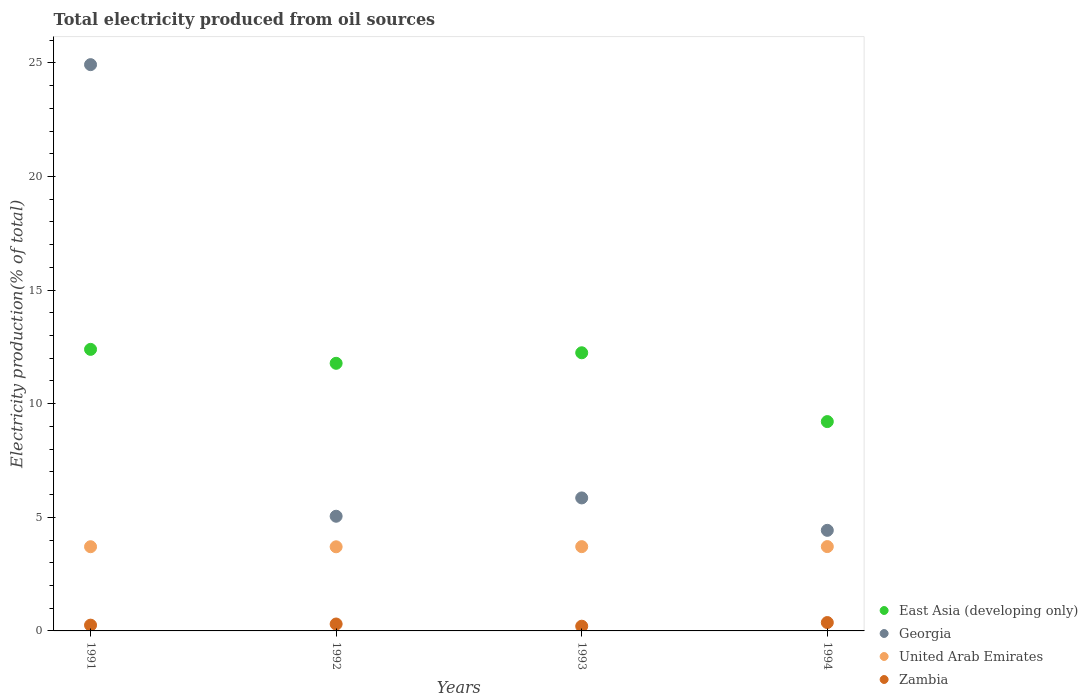How many different coloured dotlines are there?
Keep it short and to the point. 4. What is the total electricity produced in East Asia (developing only) in 1991?
Give a very brief answer. 12.39. Across all years, what is the maximum total electricity produced in United Arab Emirates?
Make the answer very short. 3.71. Across all years, what is the minimum total electricity produced in United Arab Emirates?
Provide a succinct answer. 3.7. In which year was the total electricity produced in United Arab Emirates maximum?
Ensure brevity in your answer.  1994. In which year was the total electricity produced in United Arab Emirates minimum?
Keep it short and to the point. 1992. What is the total total electricity produced in Zambia in the graph?
Provide a succinct answer. 1.13. What is the difference between the total electricity produced in Zambia in 1991 and that in 1992?
Your answer should be compact. -0.05. What is the difference between the total electricity produced in United Arab Emirates in 1993 and the total electricity produced in Zambia in 1991?
Your answer should be compact. 3.45. What is the average total electricity produced in United Arab Emirates per year?
Offer a terse response. 3.71. In the year 1993, what is the difference between the total electricity produced in East Asia (developing only) and total electricity produced in Georgia?
Offer a terse response. 6.39. What is the ratio of the total electricity produced in United Arab Emirates in 1992 to that in 1994?
Offer a terse response. 1. Is the total electricity produced in United Arab Emirates in 1993 less than that in 1994?
Your response must be concise. Yes. What is the difference between the highest and the second highest total electricity produced in Zambia?
Your response must be concise. 0.06. What is the difference between the highest and the lowest total electricity produced in East Asia (developing only)?
Offer a very short reply. 3.18. In how many years, is the total electricity produced in Georgia greater than the average total electricity produced in Georgia taken over all years?
Make the answer very short. 1. Is the sum of the total electricity produced in United Arab Emirates in 1991 and 1992 greater than the maximum total electricity produced in East Asia (developing only) across all years?
Offer a very short reply. No. Is it the case that in every year, the sum of the total electricity produced in United Arab Emirates and total electricity produced in Georgia  is greater than the total electricity produced in Zambia?
Provide a short and direct response. Yes. How many dotlines are there?
Offer a terse response. 4. How many years are there in the graph?
Make the answer very short. 4. What is the difference between two consecutive major ticks on the Y-axis?
Offer a terse response. 5. Are the values on the major ticks of Y-axis written in scientific E-notation?
Make the answer very short. No. Does the graph contain any zero values?
Keep it short and to the point. No. Does the graph contain grids?
Offer a very short reply. No. Where does the legend appear in the graph?
Ensure brevity in your answer.  Bottom right. How many legend labels are there?
Give a very brief answer. 4. What is the title of the graph?
Make the answer very short. Total electricity produced from oil sources. What is the label or title of the X-axis?
Keep it short and to the point. Years. What is the Electricity production(% of total) in East Asia (developing only) in 1991?
Your answer should be compact. 12.39. What is the Electricity production(% of total) in Georgia in 1991?
Your response must be concise. 24.92. What is the Electricity production(% of total) in United Arab Emirates in 1991?
Your response must be concise. 3.71. What is the Electricity production(% of total) in Zambia in 1991?
Offer a very short reply. 0.25. What is the Electricity production(% of total) in East Asia (developing only) in 1992?
Offer a very short reply. 11.78. What is the Electricity production(% of total) of Georgia in 1992?
Make the answer very short. 5.05. What is the Electricity production(% of total) of United Arab Emirates in 1992?
Ensure brevity in your answer.  3.7. What is the Electricity production(% of total) in Zambia in 1992?
Your answer should be compact. 0.3. What is the Electricity production(% of total) of East Asia (developing only) in 1993?
Give a very brief answer. 12.24. What is the Electricity production(% of total) of Georgia in 1993?
Give a very brief answer. 5.85. What is the Electricity production(% of total) of United Arab Emirates in 1993?
Ensure brevity in your answer.  3.71. What is the Electricity production(% of total) in Zambia in 1993?
Your answer should be very brief. 0.21. What is the Electricity production(% of total) in East Asia (developing only) in 1994?
Keep it short and to the point. 9.21. What is the Electricity production(% of total) in Georgia in 1994?
Offer a terse response. 4.43. What is the Electricity production(% of total) of United Arab Emirates in 1994?
Offer a terse response. 3.71. What is the Electricity production(% of total) in Zambia in 1994?
Offer a terse response. 0.37. Across all years, what is the maximum Electricity production(% of total) of East Asia (developing only)?
Keep it short and to the point. 12.39. Across all years, what is the maximum Electricity production(% of total) in Georgia?
Provide a succinct answer. 24.92. Across all years, what is the maximum Electricity production(% of total) in United Arab Emirates?
Offer a terse response. 3.71. Across all years, what is the maximum Electricity production(% of total) of Zambia?
Offer a very short reply. 0.37. Across all years, what is the minimum Electricity production(% of total) of East Asia (developing only)?
Your answer should be compact. 9.21. Across all years, what is the minimum Electricity production(% of total) of Georgia?
Keep it short and to the point. 4.43. Across all years, what is the minimum Electricity production(% of total) in United Arab Emirates?
Provide a succinct answer. 3.7. Across all years, what is the minimum Electricity production(% of total) of Zambia?
Your response must be concise. 0.21. What is the total Electricity production(% of total) of East Asia (developing only) in the graph?
Keep it short and to the point. 45.63. What is the total Electricity production(% of total) of Georgia in the graph?
Provide a short and direct response. 40.25. What is the total Electricity production(% of total) in United Arab Emirates in the graph?
Provide a succinct answer. 14.83. What is the total Electricity production(% of total) in Zambia in the graph?
Offer a terse response. 1.13. What is the difference between the Electricity production(% of total) of East Asia (developing only) in 1991 and that in 1992?
Give a very brief answer. 0.61. What is the difference between the Electricity production(% of total) in Georgia in 1991 and that in 1992?
Your response must be concise. 19.88. What is the difference between the Electricity production(% of total) of United Arab Emirates in 1991 and that in 1992?
Your answer should be compact. 0. What is the difference between the Electricity production(% of total) of Zambia in 1991 and that in 1992?
Your answer should be compact. -0.05. What is the difference between the Electricity production(% of total) in East Asia (developing only) in 1991 and that in 1993?
Your response must be concise. 0.15. What is the difference between the Electricity production(% of total) in Georgia in 1991 and that in 1993?
Your answer should be compact. 19.07. What is the difference between the Electricity production(% of total) of United Arab Emirates in 1991 and that in 1993?
Give a very brief answer. -0. What is the difference between the Electricity production(% of total) of Zambia in 1991 and that in 1993?
Your answer should be very brief. 0.05. What is the difference between the Electricity production(% of total) of East Asia (developing only) in 1991 and that in 1994?
Provide a succinct answer. 3.18. What is the difference between the Electricity production(% of total) of Georgia in 1991 and that in 1994?
Make the answer very short. 20.5. What is the difference between the Electricity production(% of total) in United Arab Emirates in 1991 and that in 1994?
Ensure brevity in your answer.  -0.01. What is the difference between the Electricity production(% of total) in Zambia in 1991 and that in 1994?
Ensure brevity in your answer.  -0.11. What is the difference between the Electricity production(% of total) of East Asia (developing only) in 1992 and that in 1993?
Provide a short and direct response. -0.46. What is the difference between the Electricity production(% of total) in Georgia in 1992 and that in 1993?
Give a very brief answer. -0.81. What is the difference between the Electricity production(% of total) of United Arab Emirates in 1992 and that in 1993?
Ensure brevity in your answer.  -0.01. What is the difference between the Electricity production(% of total) in Zambia in 1992 and that in 1993?
Keep it short and to the point. 0.1. What is the difference between the Electricity production(% of total) in East Asia (developing only) in 1992 and that in 1994?
Your answer should be very brief. 2.57. What is the difference between the Electricity production(% of total) of Georgia in 1992 and that in 1994?
Provide a succinct answer. 0.62. What is the difference between the Electricity production(% of total) in United Arab Emirates in 1992 and that in 1994?
Provide a short and direct response. -0.01. What is the difference between the Electricity production(% of total) of Zambia in 1992 and that in 1994?
Offer a terse response. -0.06. What is the difference between the Electricity production(% of total) of East Asia (developing only) in 1993 and that in 1994?
Give a very brief answer. 3.03. What is the difference between the Electricity production(% of total) of Georgia in 1993 and that in 1994?
Your answer should be very brief. 1.43. What is the difference between the Electricity production(% of total) of United Arab Emirates in 1993 and that in 1994?
Keep it short and to the point. -0. What is the difference between the Electricity production(% of total) of Zambia in 1993 and that in 1994?
Make the answer very short. -0.16. What is the difference between the Electricity production(% of total) in East Asia (developing only) in 1991 and the Electricity production(% of total) in Georgia in 1992?
Make the answer very short. 7.34. What is the difference between the Electricity production(% of total) in East Asia (developing only) in 1991 and the Electricity production(% of total) in United Arab Emirates in 1992?
Make the answer very short. 8.69. What is the difference between the Electricity production(% of total) of East Asia (developing only) in 1991 and the Electricity production(% of total) of Zambia in 1992?
Provide a short and direct response. 12.09. What is the difference between the Electricity production(% of total) of Georgia in 1991 and the Electricity production(% of total) of United Arab Emirates in 1992?
Give a very brief answer. 21.22. What is the difference between the Electricity production(% of total) in Georgia in 1991 and the Electricity production(% of total) in Zambia in 1992?
Provide a short and direct response. 24.62. What is the difference between the Electricity production(% of total) in United Arab Emirates in 1991 and the Electricity production(% of total) in Zambia in 1992?
Give a very brief answer. 3.4. What is the difference between the Electricity production(% of total) in East Asia (developing only) in 1991 and the Electricity production(% of total) in Georgia in 1993?
Offer a terse response. 6.54. What is the difference between the Electricity production(% of total) of East Asia (developing only) in 1991 and the Electricity production(% of total) of United Arab Emirates in 1993?
Offer a very short reply. 8.68. What is the difference between the Electricity production(% of total) in East Asia (developing only) in 1991 and the Electricity production(% of total) in Zambia in 1993?
Provide a short and direct response. 12.18. What is the difference between the Electricity production(% of total) in Georgia in 1991 and the Electricity production(% of total) in United Arab Emirates in 1993?
Provide a succinct answer. 21.21. What is the difference between the Electricity production(% of total) of Georgia in 1991 and the Electricity production(% of total) of Zambia in 1993?
Offer a terse response. 24.72. What is the difference between the Electricity production(% of total) in United Arab Emirates in 1991 and the Electricity production(% of total) in Zambia in 1993?
Keep it short and to the point. 3.5. What is the difference between the Electricity production(% of total) of East Asia (developing only) in 1991 and the Electricity production(% of total) of Georgia in 1994?
Your response must be concise. 7.97. What is the difference between the Electricity production(% of total) of East Asia (developing only) in 1991 and the Electricity production(% of total) of United Arab Emirates in 1994?
Ensure brevity in your answer.  8.68. What is the difference between the Electricity production(% of total) in East Asia (developing only) in 1991 and the Electricity production(% of total) in Zambia in 1994?
Your answer should be compact. 12.02. What is the difference between the Electricity production(% of total) of Georgia in 1991 and the Electricity production(% of total) of United Arab Emirates in 1994?
Ensure brevity in your answer.  21.21. What is the difference between the Electricity production(% of total) of Georgia in 1991 and the Electricity production(% of total) of Zambia in 1994?
Offer a terse response. 24.55. What is the difference between the Electricity production(% of total) of United Arab Emirates in 1991 and the Electricity production(% of total) of Zambia in 1994?
Keep it short and to the point. 3.34. What is the difference between the Electricity production(% of total) in East Asia (developing only) in 1992 and the Electricity production(% of total) in Georgia in 1993?
Provide a succinct answer. 5.92. What is the difference between the Electricity production(% of total) in East Asia (developing only) in 1992 and the Electricity production(% of total) in United Arab Emirates in 1993?
Keep it short and to the point. 8.07. What is the difference between the Electricity production(% of total) in East Asia (developing only) in 1992 and the Electricity production(% of total) in Zambia in 1993?
Provide a succinct answer. 11.57. What is the difference between the Electricity production(% of total) in Georgia in 1992 and the Electricity production(% of total) in United Arab Emirates in 1993?
Keep it short and to the point. 1.34. What is the difference between the Electricity production(% of total) of Georgia in 1992 and the Electricity production(% of total) of Zambia in 1993?
Offer a terse response. 4.84. What is the difference between the Electricity production(% of total) of United Arab Emirates in 1992 and the Electricity production(% of total) of Zambia in 1993?
Ensure brevity in your answer.  3.5. What is the difference between the Electricity production(% of total) in East Asia (developing only) in 1992 and the Electricity production(% of total) in Georgia in 1994?
Ensure brevity in your answer.  7.35. What is the difference between the Electricity production(% of total) of East Asia (developing only) in 1992 and the Electricity production(% of total) of United Arab Emirates in 1994?
Provide a succinct answer. 8.07. What is the difference between the Electricity production(% of total) in East Asia (developing only) in 1992 and the Electricity production(% of total) in Zambia in 1994?
Provide a succinct answer. 11.41. What is the difference between the Electricity production(% of total) of Georgia in 1992 and the Electricity production(% of total) of United Arab Emirates in 1994?
Ensure brevity in your answer.  1.34. What is the difference between the Electricity production(% of total) in Georgia in 1992 and the Electricity production(% of total) in Zambia in 1994?
Give a very brief answer. 4.68. What is the difference between the Electricity production(% of total) in United Arab Emirates in 1992 and the Electricity production(% of total) in Zambia in 1994?
Offer a terse response. 3.33. What is the difference between the Electricity production(% of total) of East Asia (developing only) in 1993 and the Electricity production(% of total) of Georgia in 1994?
Make the answer very short. 7.82. What is the difference between the Electricity production(% of total) in East Asia (developing only) in 1993 and the Electricity production(% of total) in United Arab Emirates in 1994?
Offer a very short reply. 8.53. What is the difference between the Electricity production(% of total) of East Asia (developing only) in 1993 and the Electricity production(% of total) of Zambia in 1994?
Your answer should be very brief. 11.87. What is the difference between the Electricity production(% of total) in Georgia in 1993 and the Electricity production(% of total) in United Arab Emirates in 1994?
Give a very brief answer. 2.14. What is the difference between the Electricity production(% of total) in Georgia in 1993 and the Electricity production(% of total) in Zambia in 1994?
Provide a succinct answer. 5.49. What is the difference between the Electricity production(% of total) in United Arab Emirates in 1993 and the Electricity production(% of total) in Zambia in 1994?
Offer a terse response. 3.34. What is the average Electricity production(% of total) in East Asia (developing only) per year?
Your response must be concise. 11.41. What is the average Electricity production(% of total) of Georgia per year?
Keep it short and to the point. 10.06. What is the average Electricity production(% of total) in United Arab Emirates per year?
Your answer should be compact. 3.71. What is the average Electricity production(% of total) of Zambia per year?
Provide a succinct answer. 0.28. In the year 1991, what is the difference between the Electricity production(% of total) of East Asia (developing only) and Electricity production(% of total) of Georgia?
Make the answer very short. -12.53. In the year 1991, what is the difference between the Electricity production(% of total) of East Asia (developing only) and Electricity production(% of total) of United Arab Emirates?
Your answer should be compact. 8.69. In the year 1991, what is the difference between the Electricity production(% of total) of East Asia (developing only) and Electricity production(% of total) of Zambia?
Provide a short and direct response. 12.14. In the year 1991, what is the difference between the Electricity production(% of total) in Georgia and Electricity production(% of total) in United Arab Emirates?
Offer a terse response. 21.22. In the year 1991, what is the difference between the Electricity production(% of total) of Georgia and Electricity production(% of total) of Zambia?
Your answer should be compact. 24.67. In the year 1991, what is the difference between the Electricity production(% of total) in United Arab Emirates and Electricity production(% of total) in Zambia?
Offer a terse response. 3.45. In the year 1992, what is the difference between the Electricity production(% of total) in East Asia (developing only) and Electricity production(% of total) in Georgia?
Provide a succinct answer. 6.73. In the year 1992, what is the difference between the Electricity production(% of total) of East Asia (developing only) and Electricity production(% of total) of United Arab Emirates?
Provide a succinct answer. 8.08. In the year 1992, what is the difference between the Electricity production(% of total) in East Asia (developing only) and Electricity production(% of total) in Zambia?
Your response must be concise. 11.47. In the year 1992, what is the difference between the Electricity production(% of total) of Georgia and Electricity production(% of total) of United Arab Emirates?
Offer a very short reply. 1.34. In the year 1992, what is the difference between the Electricity production(% of total) of Georgia and Electricity production(% of total) of Zambia?
Offer a very short reply. 4.74. In the year 1992, what is the difference between the Electricity production(% of total) in United Arab Emirates and Electricity production(% of total) in Zambia?
Provide a short and direct response. 3.4. In the year 1993, what is the difference between the Electricity production(% of total) in East Asia (developing only) and Electricity production(% of total) in Georgia?
Give a very brief answer. 6.39. In the year 1993, what is the difference between the Electricity production(% of total) of East Asia (developing only) and Electricity production(% of total) of United Arab Emirates?
Keep it short and to the point. 8.53. In the year 1993, what is the difference between the Electricity production(% of total) of East Asia (developing only) and Electricity production(% of total) of Zambia?
Your answer should be very brief. 12.03. In the year 1993, what is the difference between the Electricity production(% of total) of Georgia and Electricity production(% of total) of United Arab Emirates?
Provide a short and direct response. 2.14. In the year 1993, what is the difference between the Electricity production(% of total) in Georgia and Electricity production(% of total) in Zambia?
Make the answer very short. 5.65. In the year 1993, what is the difference between the Electricity production(% of total) of United Arab Emirates and Electricity production(% of total) of Zambia?
Your answer should be very brief. 3.5. In the year 1994, what is the difference between the Electricity production(% of total) of East Asia (developing only) and Electricity production(% of total) of Georgia?
Make the answer very short. 4.79. In the year 1994, what is the difference between the Electricity production(% of total) of East Asia (developing only) and Electricity production(% of total) of United Arab Emirates?
Make the answer very short. 5.5. In the year 1994, what is the difference between the Electricity production(% of total) of East Asia (developing only) and Electricity production(% of total) of Zambia?
Your answer should be very brief. 8.84. In the year 1994, what is the difference between the Electricity production(% of total) in Georgia and Electricity production(% of total) in United Arab Emirates?
Keep it short and to the point. 0.71. In the year 1994, what is the difference between the Electricity production(% of total) in Georgia and Electricity production(% of total) in Zambia?
Provide a succinct answer. 4.06. In the year 1994, what is the difference between the Electricity production(% of total) of United Arab Emirates and Electricity production(% of total) of Zambia?
Provide a succinct answer. 3.34. What is the ratio of the Electricity production(% of total) of East Asia (developing only) in 1991 to that in 1992?
Keep it short and to the point. 1.05. What is the ratio of the Electricity production(% of total) of Georgia in 1991 to that in 1992?
Offer a very short reply. 4.94. What is the ratio of the Electricity production(% of total) in United Arab Emirates in 1991 to that in 1992?
Make the answer very short. 1. What is the ratio of the Electricity production(% of total) in Zambia in 1991 to that in 1992?
Ensure brevity in your answer.  0.84. What is the ratio of the Electricity production(% of total) of East Asia (developing only) in 1991 to that in 1993?
Keep it short and to the point. 1.01. What is the ratio of the Electricity production(% of total) in Georgia in 1991 to that in 1993?
Offer a terse response. 4.26. What is the ratio of the Electricity production(% of total) of United Arab Emirates in 1991 to that in 1993?
Keep it short and to the point. 1. What is the ratio of the Electricity production(% of total) in Zambia in 1991 to that in 1993?
Provide a short and direct response. 1.23. What is the ratio of the Electricity production(% of total) in East Asia (developing only) in 1991 to that in 1994?
Give a very brief answer. 1.34. What is the ratio of the Electricity production(% of total) in Georgia in 1991 to that in 1994?
Provide a succinct answer. 5.63. What is the ratio of the Electricity production(% of total) in United Arab Emirates in 1991 to that in 1994?
Provide a succinct answer. 1. What is the ratio of the Electricity production(% of total) in Zambia in 1991 to that in 1994?
Your answer should be very brief. 0.69. What is the ratio of the Electricity production(% of total) of East Asia (developing only) in 1992 to that in 1993?
Your response must be concise. 0.96. What is the ratio of the Electricity production(% of total) of Georgia in 1992 to that in 1993?
Keep it short and to the point. 0.86. What is the ratio of the Electricity production(% of total) in United Arab Emirates in 1992 to that in 1993?
Offer a very short reply. 1. What is the ratio of the Electricity production(% of total) in Zambia in 1992 to that in 1993?
Your answer should be very brief. 1.47. What is the ratio of the Electricity production(% of total) of East Asia (developing only) in 1992 to that in 1994?
Your response must be concise. 1.28. What is the ratio of the Electricity production(% of total) in Georgia in 1992 to that in 1994?
Your answer should be compact. 1.14. What is the ratio of the Electricity production(% of total) of Zambia in 1992 to that in 1994?
Give a very brief answer. 0.83. What is the ratio of the Electricity production(% of total) in East Asia (developing only) in 1993 to that in 1994?
Your answer should be compact. 1.33. What is the ratio of the Electricity production(% of total) of Georgia in 1993 to that in 1994?
Give a very brief answer. 1.32. What is the ratio of the Electricity production(% of total) in United Arab Emirates in 1993 to that in 1994?
Offer a very short reply. 1. What is the ratio of the Electricity production(% of total) in Zambia in 1993 to that in 1994?
Offer a very short reply. 0.56. What is the difference between the highest and the second highest Electricity production(% of total) of East Asia (developing only)?
Offer a very short reply. 0.15. What is the difference between the highest and the second highest Electricity production(% of total) in Georgia?
Keep it short and to the point. 19.07. What is the difference between the highest and the second highest Electricity production(% of total) in United Arab Emirates?
Your response must be concise. 0. What is the difference between the highest and the second highest Electricity production(% of total) of Zambia?
Offer a very short reply. 0.06. What is the difference between the highest and the lowest Electricity production(% of total) in East Asia (developing only)?
Make the answer very short. 3.18. What is the difference between the highest and the lowest Electricity production(% of total) of Georgia?
Provide a succinct answer. 20.5. What is the difference between the highest and the lowest Electricity production(% of total) in United Arab Emirates?
Ensure brevity in your answer.  0.01. What is the difference between the highest and the lowest Electricity production(% of total) in Zambia?
Ensure brevity in your answer.  0.16. 